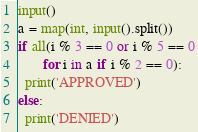<code> <loc_0><loc_0><loc_500><loc_500><_Python_>input()
a = map(int, input().split())
if all(i % 3 == 0 or i % 5 == 0
       for i in a if i % 2 == 0):
  print('APPROVED')
else:
  print('DENIED')</code> 